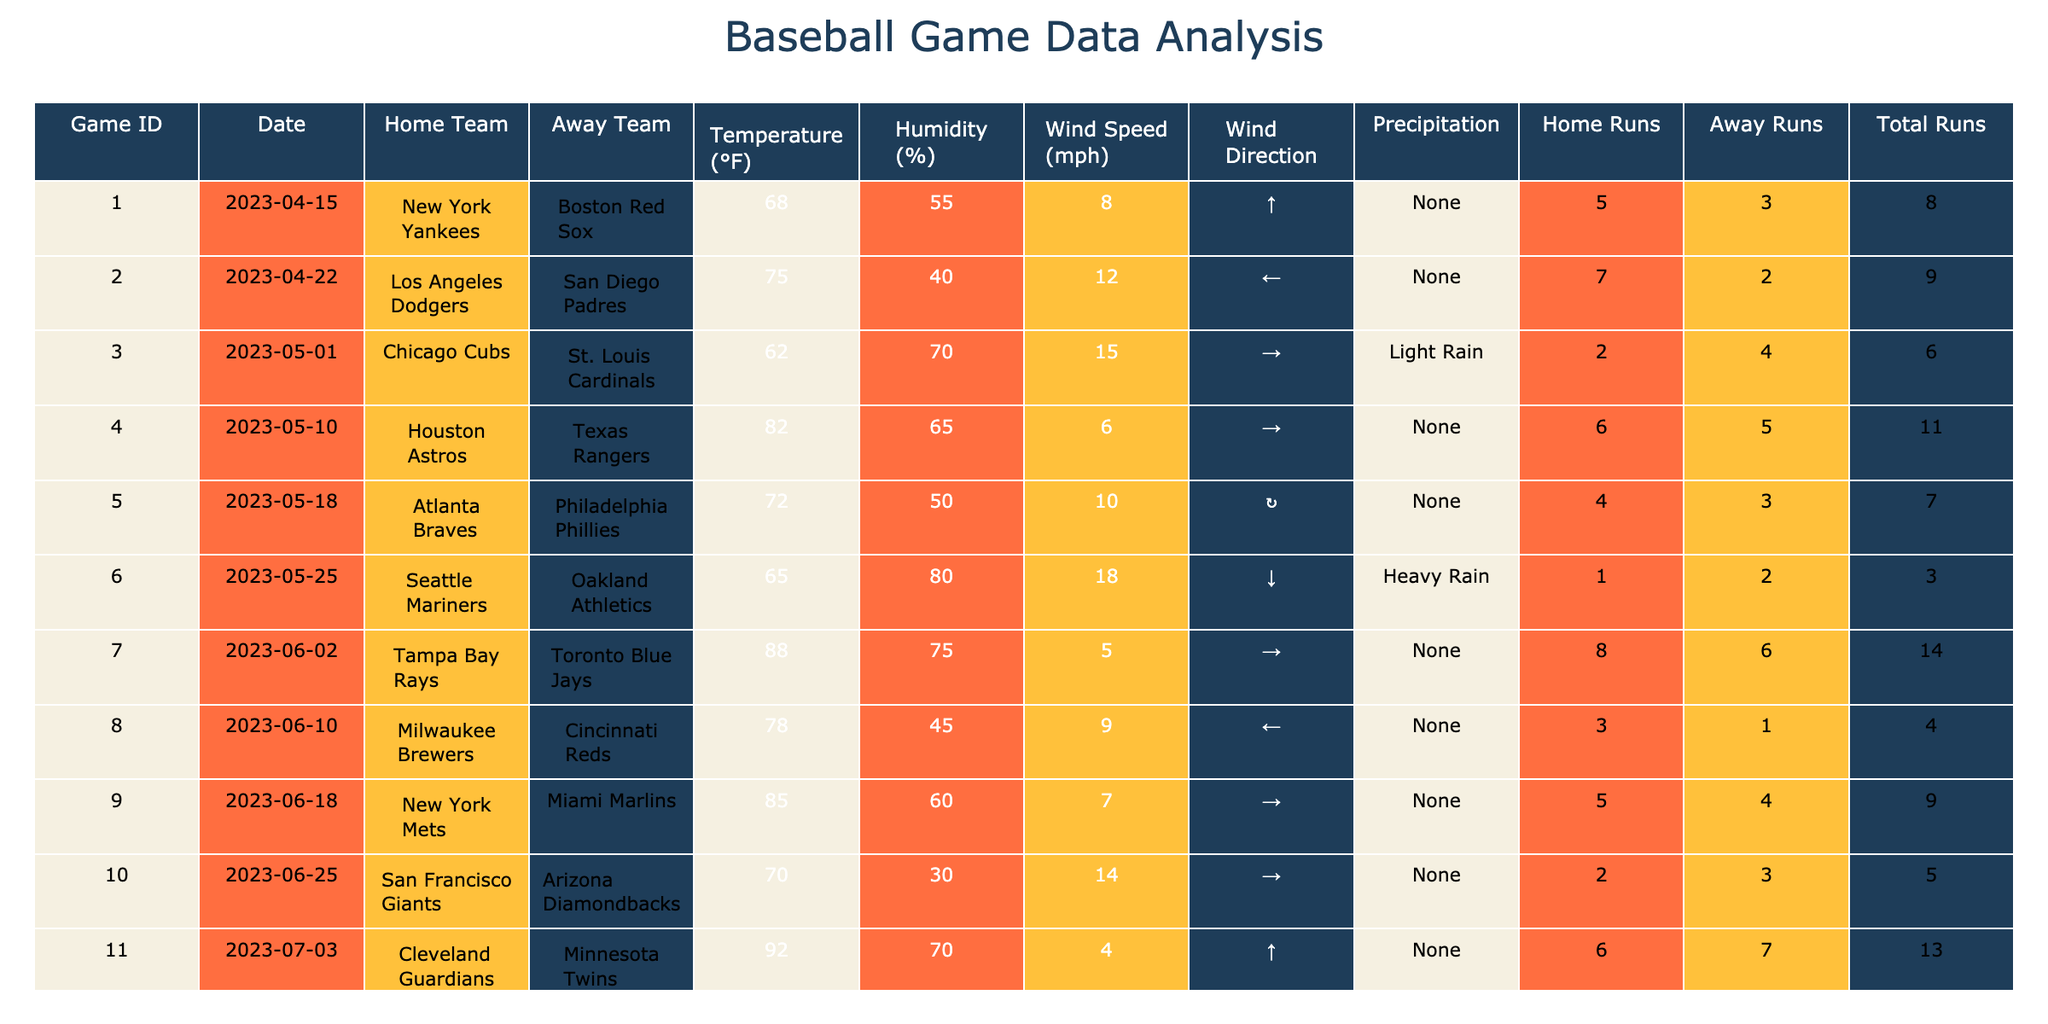What is the total number of runs scored in game 7? In game 7, the Total Runs column shows a value of 14.
Answer: 14 What was the highest temperature recorded in the games? The Temperature column shows a maximum value of 92°F in game 11.
Answer: 92°F Did the New York Yankees win their game? The Home Runs for the New York Yankees in game 1 were 5, while the Away Runs for the Boston Red Sox were 3, indicating the Yankees won.
Answer: Yes How many games had a wind speed greater than 10 mph? There are 6 games where the Wind Speed is greater than 10 mph (with values of 12, 15, 18, 14, and 11).
Answer: 6 What was the average number of home runs scored across all games? Total Home Runs scored is 56 (sum of all home runs), and there are 15 games. Therefore, the average is 56 / 15 ≈ 3.73.
Answer: 3.73 Which game had the most total runs, and what was the score? Game 12 had the highest total runs at 17 (9 home runs from the Rockies + 8 from the Nationals).
Answer: Game 12, 17 runs Was there any precipitation reported in game 6? The 'Precipitation' column for game 6 indicates "Heavy Rain," meaning precipitation was reported.
Answer: Yes What is the difference between the highest and lowest humidity levels recorded? The highest humidity is 80% (game 6) and the lowest is 30% (game 10). The difference is 80 - 30 = 50%.
Answer: 50% Which team played at home on June 18, 2023, and what was the outcome? The New York Mets played at home against the Miami Marlins and scored 5 runs while the Marlins scored 4 runs, meaning the Mets won.
Answer: New York Mets won Can you find a correlation between high temperatures and the number of runs scored? Observing the data, as temperatures increase (games with 82°F and 90°F), total runs also increase (11 and 10 respectively), suggesting a possible positive correlation.
Answer: Positive correlation 